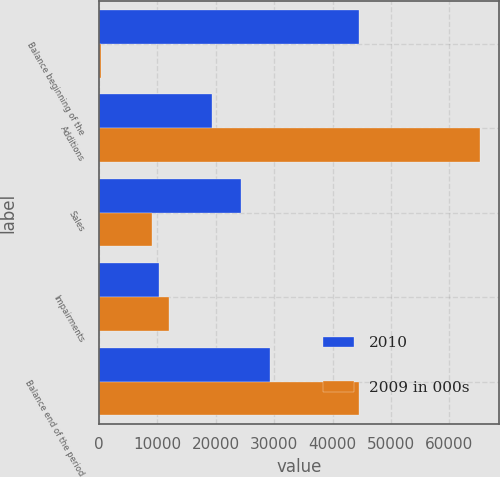Convert chart to OTSL. <chart><loc_0><loc_0><loc_500><loc_500><stacked_bar_chart><ecel><fcel>Balance beginning of the<fcel>Additions<fcel>Sales<fcel>Impairments<fcel>Balance end of the period<nl><fcel>2010<fcel>44533<fcel>19341<fcel>24308<fcel>10314<fcel>29252<nl><fcel>2009 in 000s<fcel>350<fcel>65171<fcel>9072<fcel>11916<fcel>44533<nl></chart> 